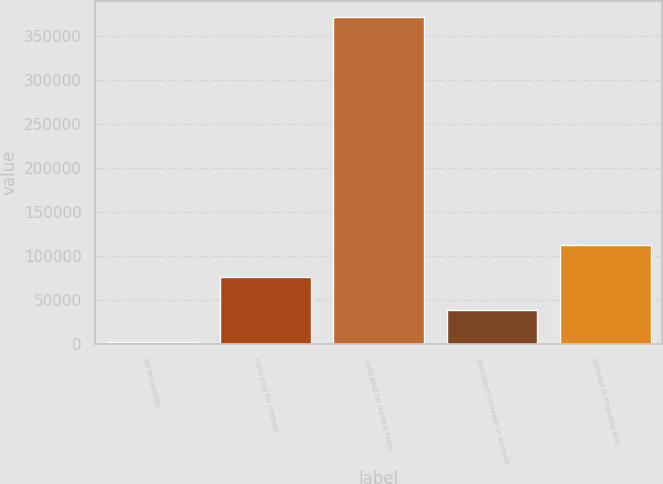Convert chart to OTSL. <chart><loc_0><loc_0><loc_500><loc_500><bar_chart><fcel>(In thousands)<fcel>Cash paid for interest<fcel>Cash paid for income taxes<fcel>(Decrease) increase in accrued<fcel>Increase in financing and<nl><fcel>2017<fcel>75859<fcel>371227<fcel>38938<fcel>112780<nl></chart> 